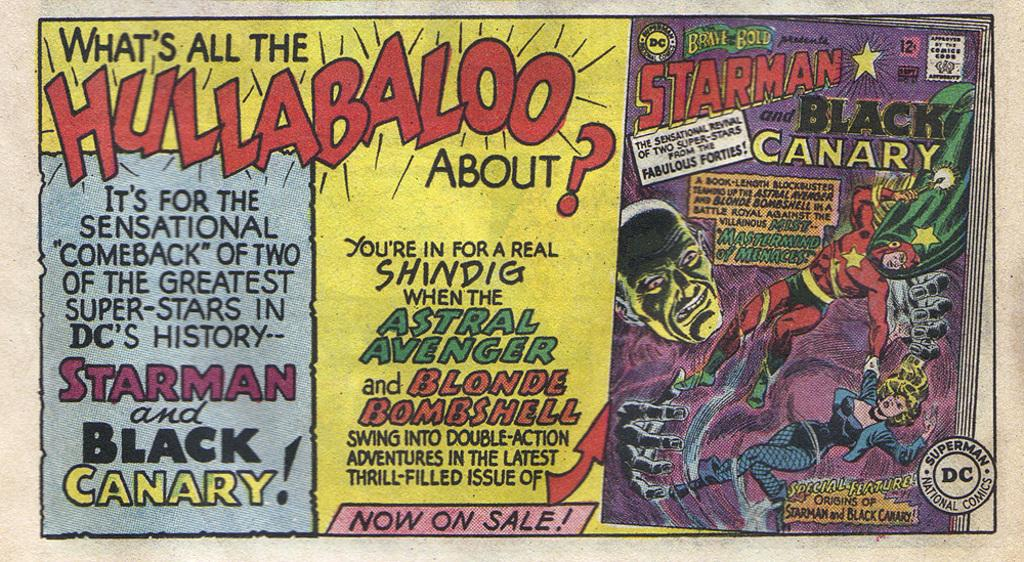<image>
Present a compact description of the photo's key features. Three different comic books about the black canary 